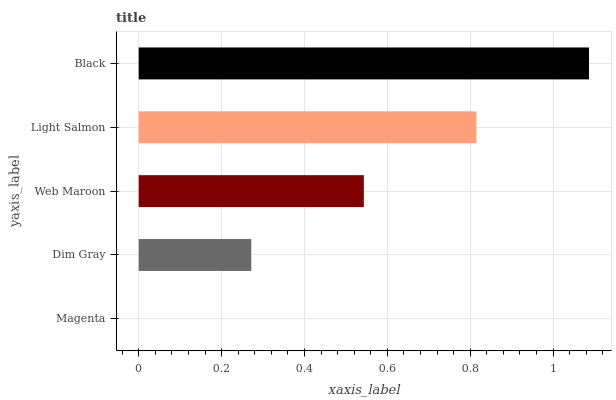Is Magenta the minimum?
Answer yes or no. Yes. Is Black the maximum?
Answer yes or no. Yes. Is Dim Gray the minimum?
Answer yes or no. No. Is Dim Gray the maximum?
Answer yes or no. No. Is Dim Gray greater than Magenta?
Answer yes or no. Yes. Is Magenta less than Dim Gray?
Answer yes or no. Yes. Is Magenta greater than Dim Gray?
Answer yes or no. No. Is Dim Gray less than Magenta?
Answer yes or no. No. Is Web Maroon the high median?
Answer yes or no. Yes. Is Web Maroon the low median?
Answer yes or no. Yes. Is Light Salmon the high median?
Answer yes or no. No. Is Light Salmon the low median?
Answer yes or no. No. 